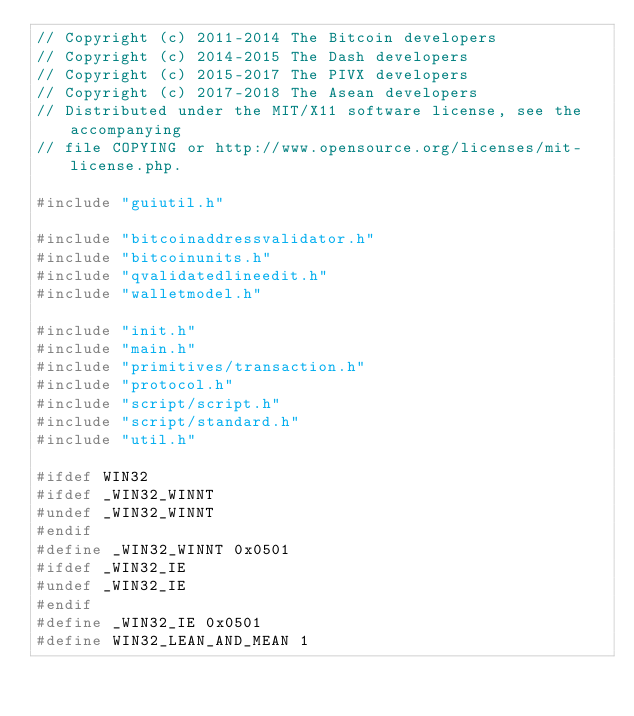<code> <loc_0><loc_0><loc_500><loc_500><_C++_>// Copyright (c) 2011-2014 The Bitcoin developers
// Copyright (c) 2014-2015 The Dash developers
// Copyright (c) 2015-2017 The PIVX developers
// Copyright (c) 2017-2018 The Asean developers
// Distributed under the MIT/X11 software license, see the accompanying
// file COPYING or http://www.opensource.org/licenses/mit-license.php.

#include "guiutil.h"

#include "bitcoinaddressvalidator.h"
#include "bitcoinunits.h"
#include "qvalidatedlineedit.h"
#include "walletmodel.h"

#include "init.h"
#include "main.h"
#include "primitives/transaction.h"
#include "protocol.h"
#include "script/script.h"
#include "script/standard.h"
#include "util.h"

#ifdef WIN32
#ifdef _WIN32_WINNT
#undef _WIN32_WINNT
#endif
#define _WIN32_WINNT 0x0501
#ifdef _WIN32_IE
#undef _WIN32_IE
#endif
#define _WIN32_IE 0x0501
#define WIN32_LEAN_AND_MEAN 1</code> 